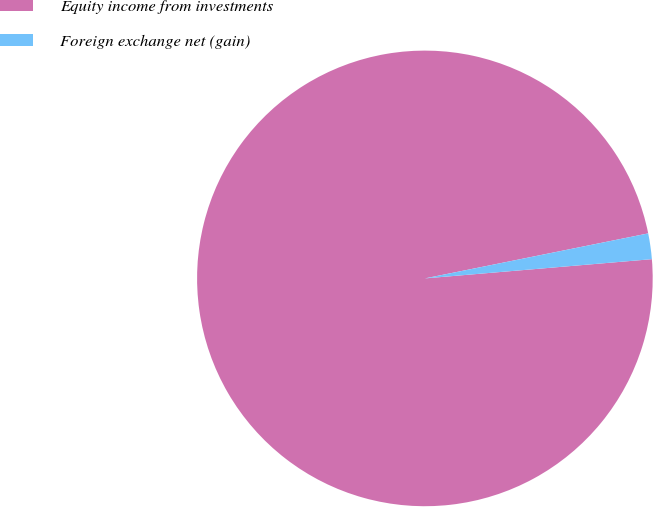Convert chart. <chart><loc_0><loc_0><loc_500><loc_500><pie_chart><fcel>Equity income from investments<fcel>Foreign exchange net (gain)<nl><fcel>98.18%<fcel>1.82%<nl></chart> 